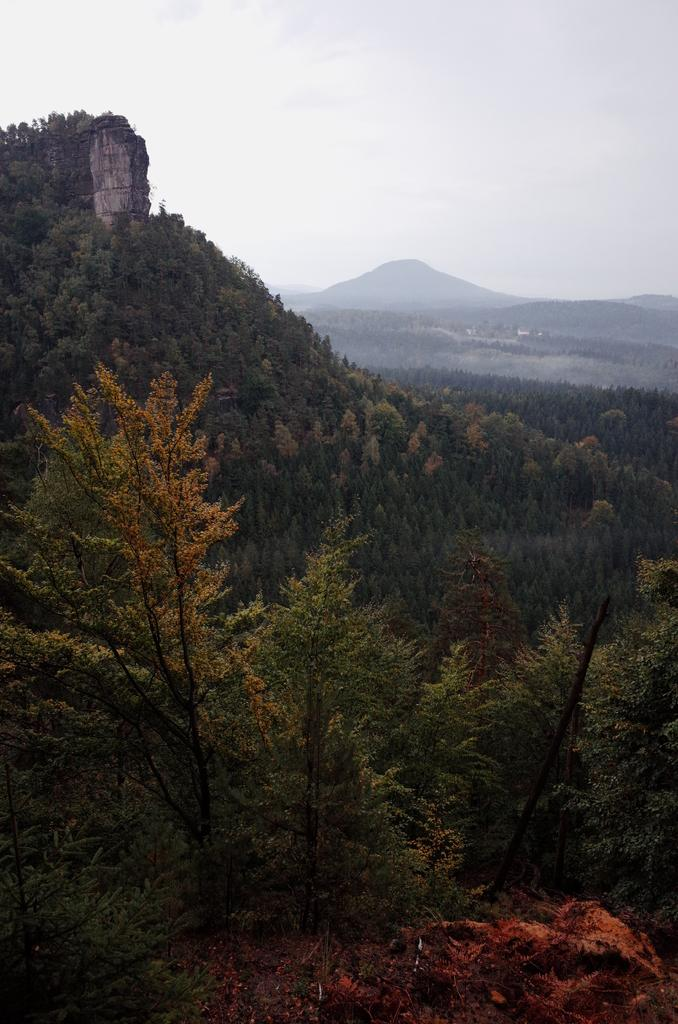What type of natural elements can be seen in the image? There are trees in the image. What type of landscape feature is visible in the background? There are mountains in the background of the image. What is the condition of the sky in the background? The sky is clear in the background of the image. How many people are working on the road in the image? There is no road or people working in the image; it features trees and mountains with a clear sky. 